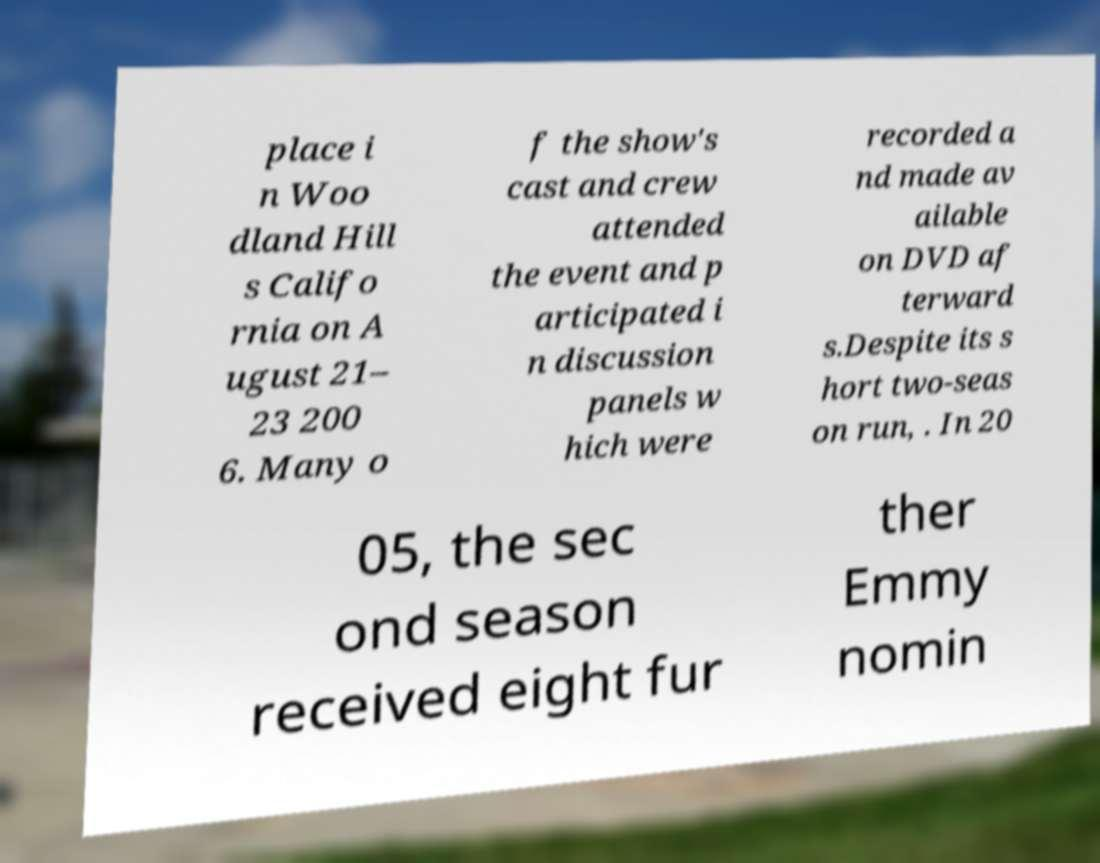Please identify and transcribe the text found in this image. place i n Woo dland Hill s Califo rnia on A ugust 21– 23 200 6. Many o f the show's cast and crew attended the event and p articipated i n discussion panels w hich were recorded a nd made av ailable on DVD af terward s.Despite its s hort two-seas on run, . In 20 05, the sec ond season received eight fur ther Emmy nomin 